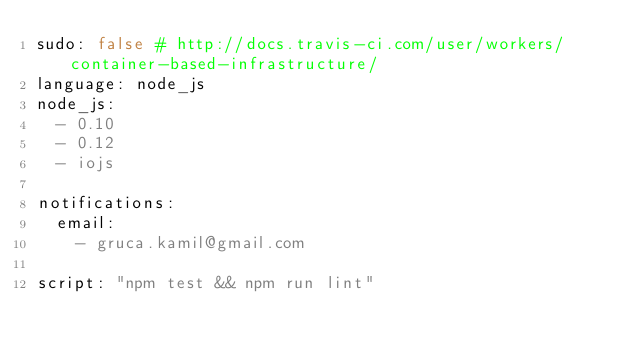Convert code to text. <code><loc_0><loc_0><loc_500><loc_500><_YAML_>sudo: false # http://docs.travis-ci.com/user/workers/container-based-infrastructure/
language: node_js
node_js:
  - 0.10
  - 0.12
  - iojs

notifications:
  email:
    - gruca.kamil@gmail.com

script: "npm test && npm run lint"
</code> 